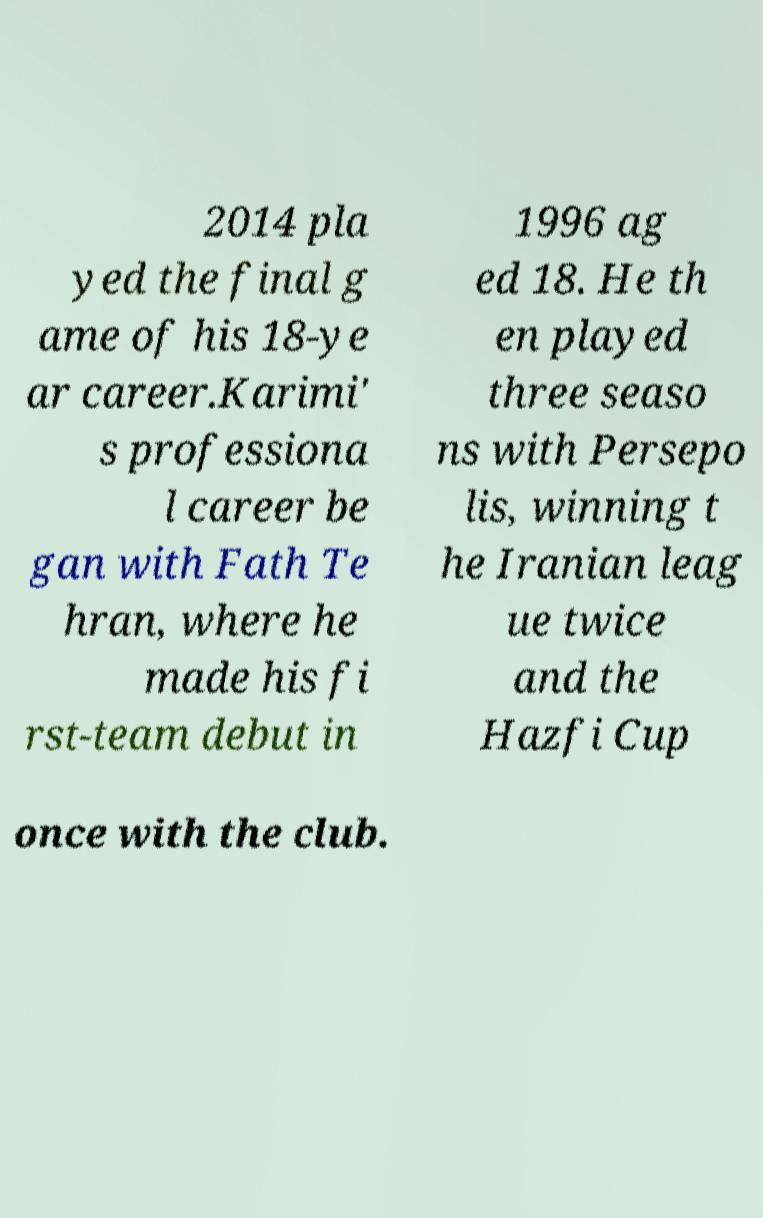Can you accurately transcribe the text from the provided image for me? 2014 pla yed the final g ame of his 18-ye ar career.Karimi' s professiona l career be gan with Fath Te hran, where he made his fi rst-team debut in 1996 ag ed 18. He th en played three seaso ns with Persepo lis, winning t he Iranian leag ue twice and the Hazfi Cup once with the club. 